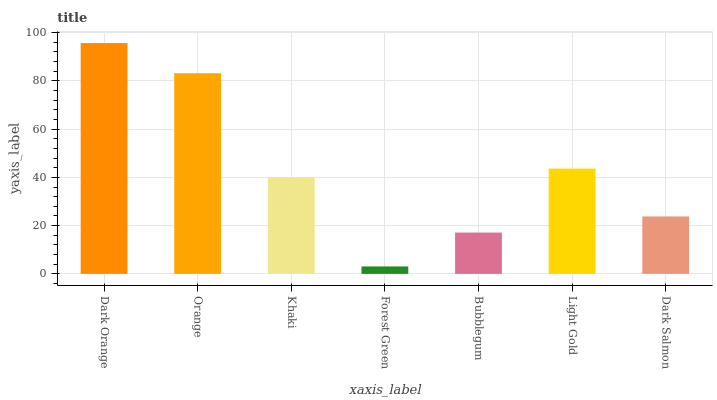Is Forest Green the minimum?
Answer yes or no. Yes. Is Dark Orange the maximum?
Answer yes or no. Yes. Is Orange the minimum?
Answer yes or no. No. Is Orange the maximum?
Answer yes or no. No. Is Dark Orange greater than Orange?
Answer yes or no. Yes. Is Orange less than Dark Orange?
Answer yes or no. Yes. Is Orange greater than Dark Orange?
Answer yes or no. No. Is Dark Orange less than Orange?
Answer yes or no. No. Is Khaki the high median?
Answer yes or no. Yes. Is Khaki the low median?
Answer yes or no. Yes. Is Orange the high median?
Answer yes or no. No. Is Dark Salmon the low median?
Answer yes or no. No. 